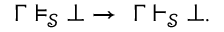<formula> <loc_0><loc_0><loc_500><loc_500>\Gamma \models _ { \mathcal { S } } \bot \to \ \Gamma \vdash _ { \mathcal { S } } \bot .</formula> 